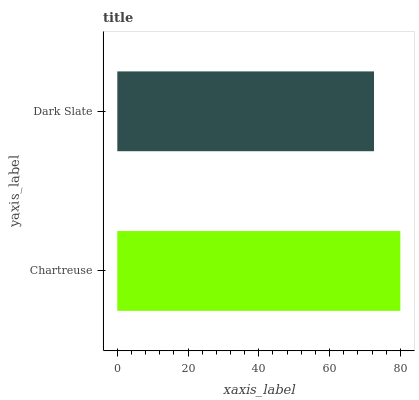Is Dark Slate the minimum?
Answer yes or no. Yes. Is Chartreuse the maximum?
Answer yes or no. Yes. Is Dark Slate the maximum?
Answer yes or no. No. Is Chartreuse greater than Dark Slate?
Answer yes or no. Yes. Is Dark Slate less than Chartreuse?
Answer yes or no. Yes. Is Dark Slate greater than Chartreuse?
Answer yes or no. No. Is Chartreuse less than Dark Slate?
Answer yes or no. No. Is Chartreuse the high median?
Answer yes or no. Yes. Is Dark Slate the low median?
Answer yes or no. Yes. Is Dark Slate the high median?
Answer yes or no. No. Is Chartreuse the low median?
Answer yes or no. No. 